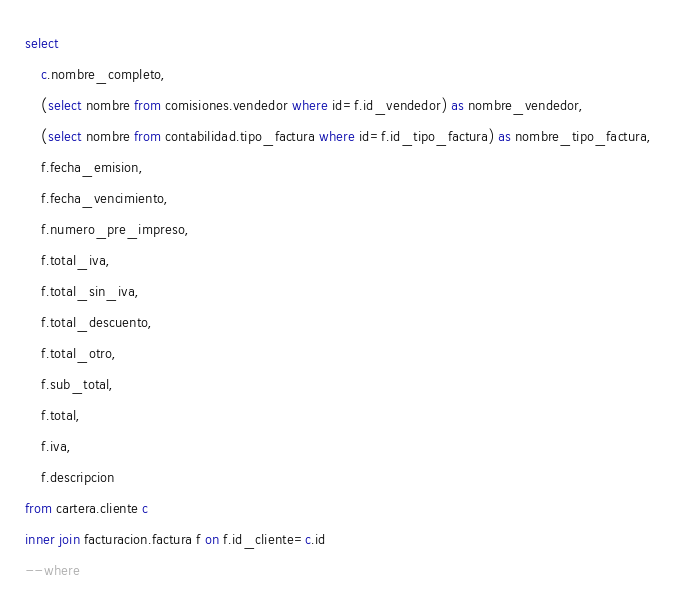<code> <loc_0><loc_0><loc_500><loc_500><_SQL_>select 
	c.nombre_completo,
	(select nombre from comisiones.vendedor where id=f.id_vendedor) as nombre_vendedor,
	(select nombre from contabilidad.tipo_factura where id=f.id_tipo_factura) as nombre_tipo_factura,
	f.fecha_emision,
	f.fecha_vencimiento,
	f.numero_pre_impreso,
	f.total_iva,
	f.total_sin_iva,
	f.total_descuento,
	f.total_otro,
	f.sub_total,
	f.total,
	f.iva,
	f.descripcion
from cartera.cliente c
inner join facturacion.factura f on f.id_cliente=c.id
--where</code> 